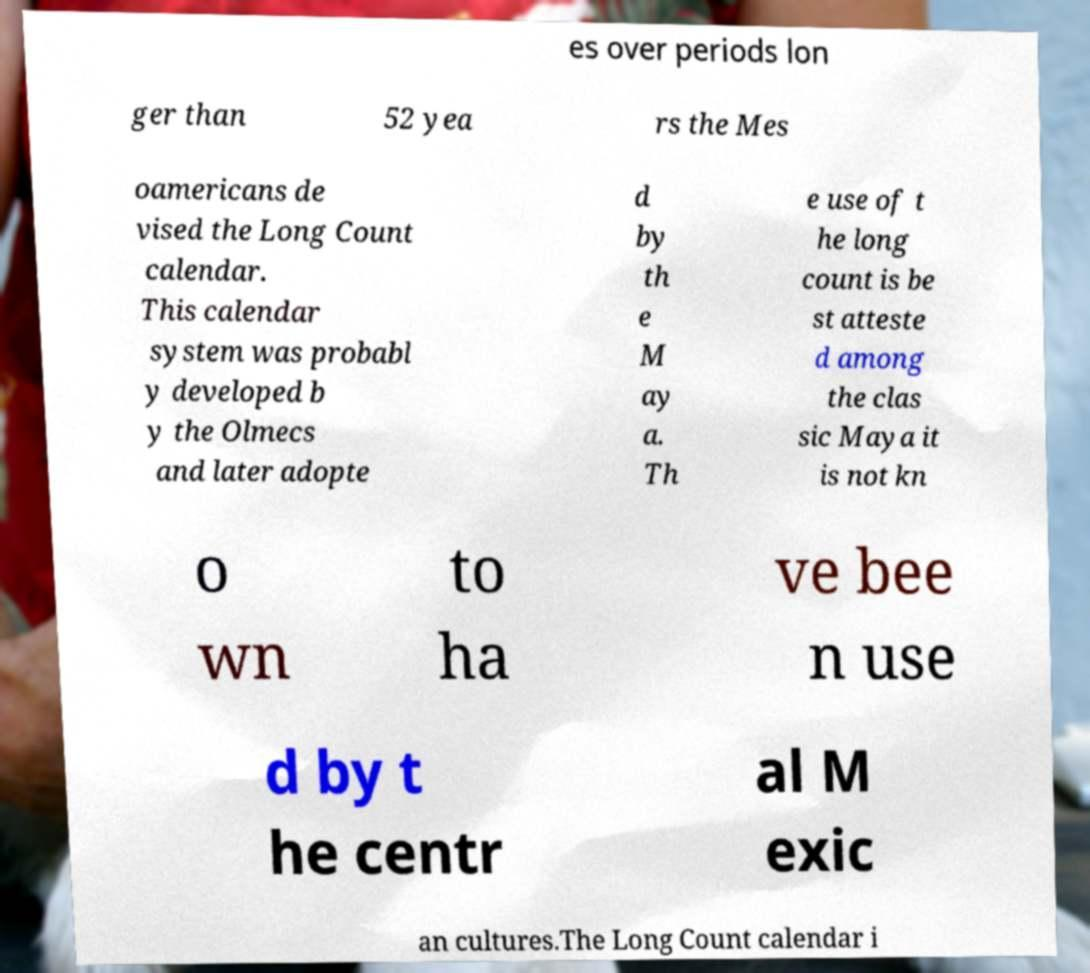Could you assist in decoding the text presented in this image and type it out clearly? es over periods lon ger than 52 yea rs the Mes oamericans de vised the Long Count calendar. This calendar system was probabl y developed b y the Olmecs and later adopte d by th e M ay a. Th e use of t he long count is be st atteste d among the clas sic Maya it is not kn o wn to ha ve bee n use d by t he centr al M exic an cultures.The Long Count calendar i 